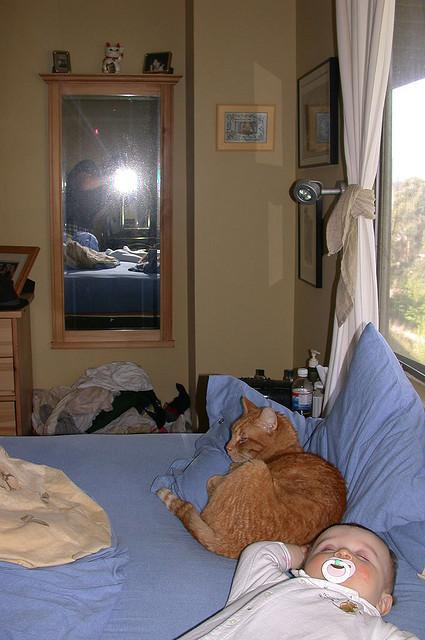What is the cause of the bright spot in the center of the mirror on the wall? camera flash 